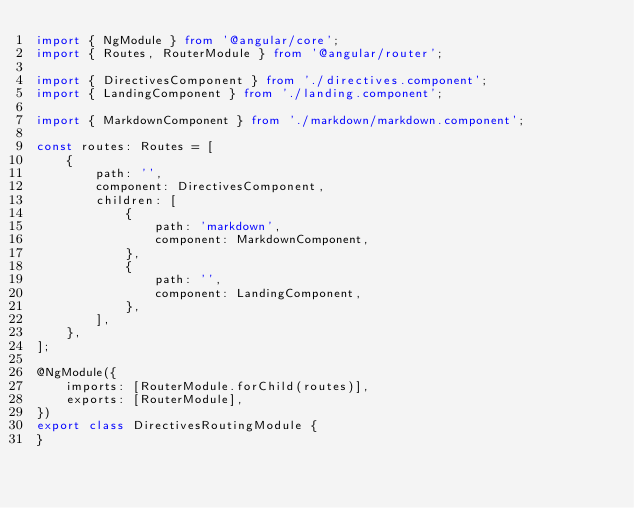<code> <loc_0><loc_0><loc_500><loc_500><_TypeScript_>import { NgModule } from '@angular/core';
import { Routes, RouterModule } from '@angular/router';

import { DirectivesComponent } from './directives.component';
import { LandingComponent } from './landing.component';

import { MarkdownComponent } from './markdown/markdown.component';

const routes: Routes = [
    {
        path: '',
        component: DirectivesComponent,
        children: [
            {
                path: 'markdown',
                component: MarkdownComponent,
            },
            {
                path: '',
                component: LandingComponent,
            },
        ],
    },
];

@NgModule({
    imports: [RouterModule.forChild(routes)],
    exports: [RouterModule],
})
export class DirectivesRoutingModule {
}
</code> 